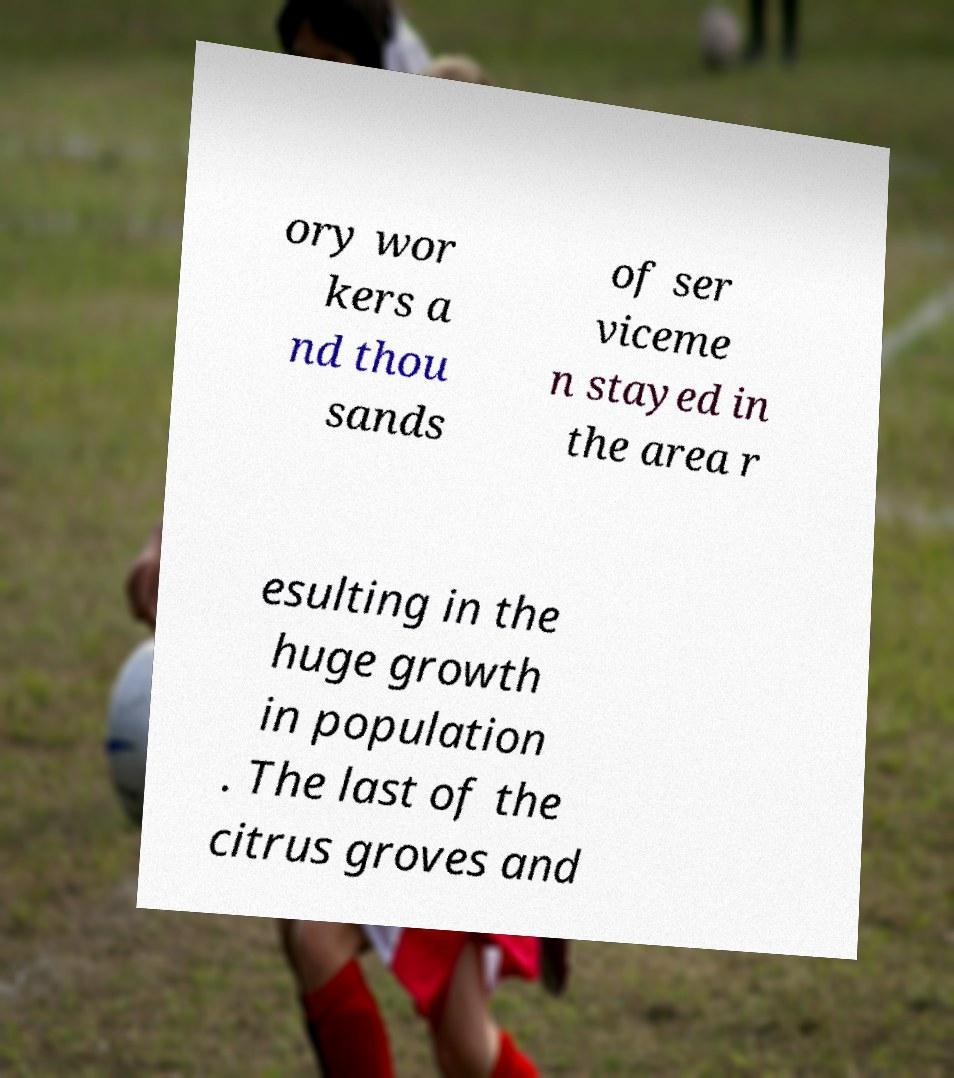For documentation purposes, I need the text within this image transcribed. Could you provide that? ory wor kers a nd thou sands of ser viceme n stayed in the area r esulting in the huge growth in population . The last of the citrus groves and 